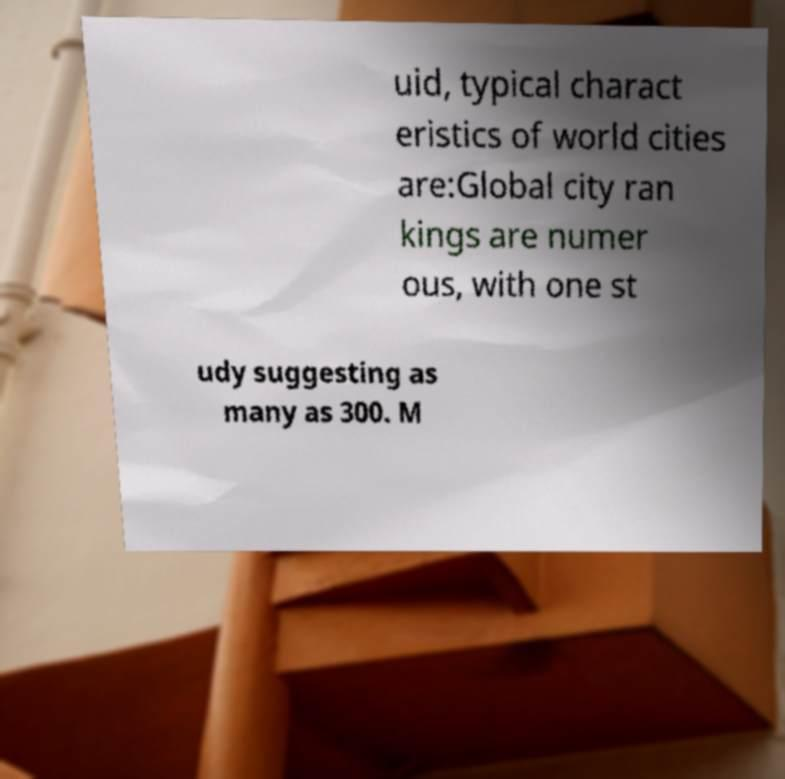Could you assist in decoding the text presented in this image and type it out clearly? uid, typical charact eristics of world cities are:Global city ran kings are numer ous, with one st udy suggesting as many as 300. M 